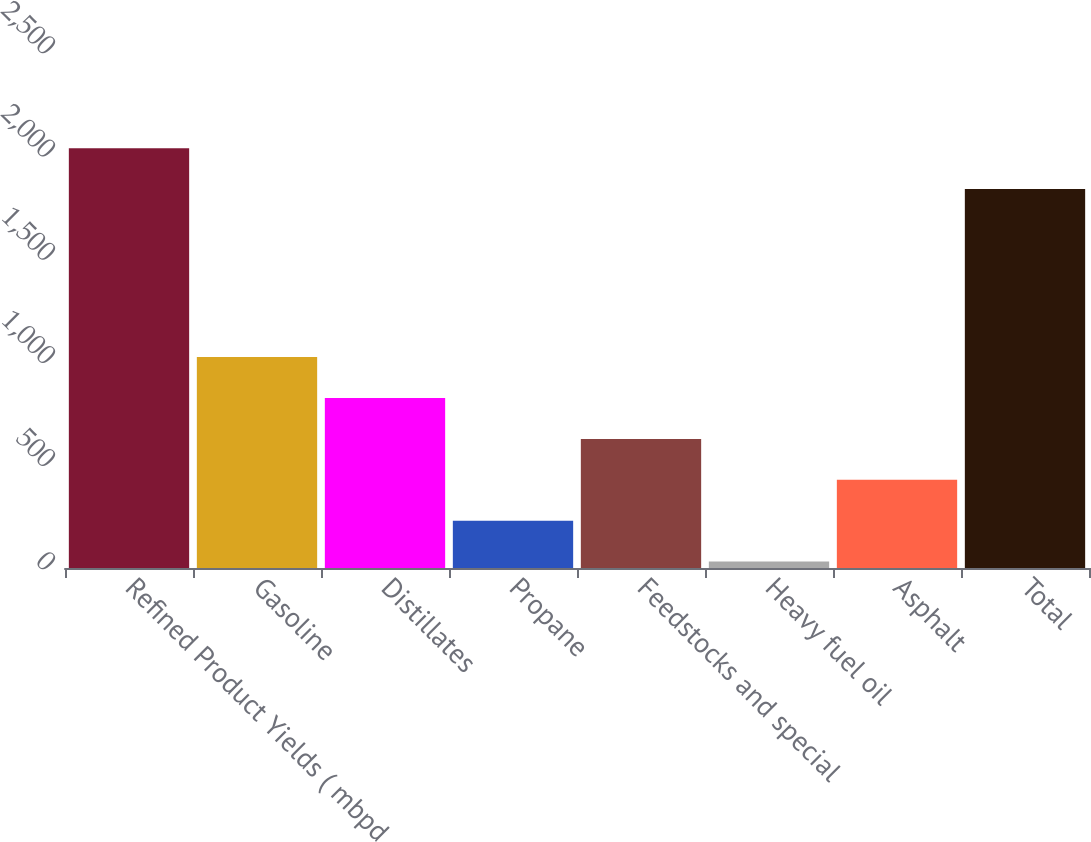Convert chart to OTSL. <chart><loc_0><loc_0><loc_500><loc_500><bar_chart><fcel>Refined Product Yields ( mbpd<fcel>Gasoline<fcel>Distillates<fcel>Propane<fcel>Feedstocks and special<fcel>Heavy fuel oil<fcel>Asphalt<fcel>Total<nl><fcel>2034.2<fcel>1022<fcel>823.8<fcel>229.2<fcel>625.6<fcel>31<fcel>427.4<fcel>1836<nl></chart> 